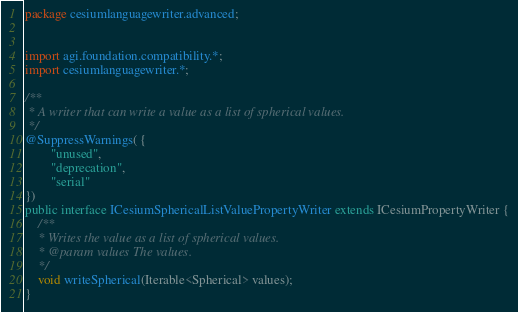Convert code to text. <code><loc_0><loc_0><loc_500><loc_500><_Java_>package cesiumlanguagewriter.advanced;


import agi.foundation.compatibility.*;
import cesiumlanguagewriter.*;

/**
 * A writer that can write a value as a list of spherical values.
 */
@SuppressWarnings( {
        "unused",
        "deprecation",
        "serial"
})
public interface ICesiumSphericalListValuePropertyWriter extends ICesiumPropertyWriter {
    /**
    * Writes the value as a list of spherical values.
    * @param values The values.
    */
    void writeSpherical(Iterable<Spherical> values);
}</code> 